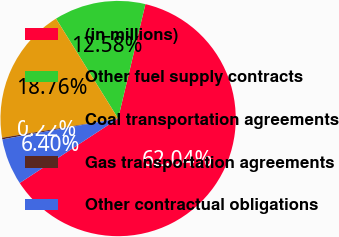<chart> <loc_0><loc_0><loc_500><loc_500><pie_chart><fcel>(in millions)<fcel>Other fuel supply contracts<fcel>Coal transportation agreements<fcel>Gas transportation agreements<fcel>Other contractual obligations<nl><fcel>62.04%<fcel>12.58%<fcel>18.76%<fcel>0.22%<fcel>6.4%<nl></chart> 